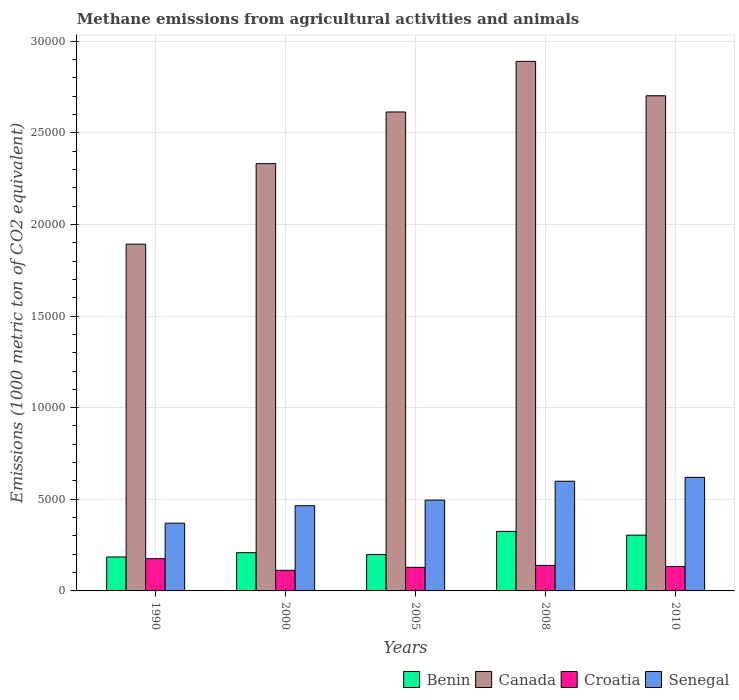How many groups of bars are there?
Make the answer very short. 5. Are the number of bars per tick equal to the number of legend labels?
Provide a short and direct response. Yes. How many bars are there on the 3rd tick from the left?
Provide a succinct answer. 4. How many bars are there on the 4th tick from the right?
Provide a succinct answer. 4. In how many cases, is the number of bars for a given year not equal to the number of legend labels?
Your response must be concise. 0. What is the amount of methane emitted in Canada in 2008?
Your response must be concise. 2.89e+04. Across all years, what is the maximum amount of methane emitted in Canada?
Your response must be concise. 2.89e+04. Across all years, what is the minimum amount of methane emitted in Benin?
Give a very brief answer. 1853. What is the total amount of methane emitted in Canada in the graph?
Make the answer very short. 1.24e+05. What is the difference between the amount of methane emitted in Croatia in 2000 and that in 2005?
Offer a very short reply. -160.7. What is the difference between the amount of methane emitted in Senegal in 2010 and the amount of methane emitted in Benin in 1990?
Give a very brief answer. 4346.1. What is the average amount of methane emitted in Benin per year?
Provide a short and direct response. 2444.08. In the year 2010, what is the difference between the amount of methane emitted in Canada and amount of methane emitted in Benin?
Offer a terse response. 2.40e+04. In how many years, is the amount of methane emitted in Croatia greater than 14000 1000 metric ton?
Your answer should be very brief. 0. What is the ratio of the amount of methane emitted in Croatia in 2005 to that in 2008?
Give a very brief answer. 0.92. What is the difference between the highest and the second highest amount of methane emitted in Croatia?
Offer a terse response. 366.3. What is the difference between the highest and the lowest amount of methane emitted in Canada?
Offer a very short reply. 9973.1. Is the sum of the amount of methane emitted in Benin in 1990 and 2010 greater than the maximum amount of methane emitted in Canada across all years?
Your answer should be very brief. No. Is it the case that in every year, the sum of the amount of methane emitted in Senegal and amount of methane emitted in Benin is greater than the sum of amount of methane emitted in Croatia and amount of methane emitted in Canada?
Your answer should be very brief. No. What does the 3rd bar from the left in 2000 represents?
Provide a short and direct response. Croatia. What does the 2nd bar from the right in 1990 represents?
Make the answer very short. Croatia. Is it the case that in every year, the sum of the amount of methane emitted in Canada and amount of methane emitted in Benin is greater than the amount of methane emitted in Croatia?
Offer a very short reply. Yes. Are all the bars in the graph horizontal?
Offer a very short reply. No. What is the difference between two consecutive major ticks on the Y-axis?
Make the answer very short. 5000. Does the graph contain any zero values?
Provide a succinct answer. No. Does the graph contain grids?
Offer a very short reply. Yes. How many legend labels are there?
Ensure brevity in your answer.  4. What is the title of the graph?
Offer a very short reply. Methane emissions from agricultural activities and animals. Does "Myanmar" appear as one of the legend labels in the graph?
Give a very brief answer. No. What is the label or title of the X-axis?
Provide a succinct answer. Years. What is the label or title of the Y-axis?
Your answer should be compact. Emissions (1000 metric ton of CO2 equivalent). What is the Emissions (1000 metric ton of CO2 equivalent) of Benin in 1990?
Give a very brief answer. 1853. What is the Emissions (1000 metric ton of CO2 equivalent) in Canada in 1990?
Your answer should be compact. 1.89e+04. What is the Emissions (1000 metric ton of CO2 equivalent) in Croatia in 1990?
Provide a short and direct response. 1759.1. What is the Emissions (1000 metric ton of CO2 equivalent) in Senegal in 1990?
Your answer should be compact. 3695.6. What is the Emissions (1000 metric ton of CO2 equivalent) of Benin in 2000?
Offer a very short reply. 2086.3. What is the Emissions (1000 metric ton of CO2 equivalent) in Canada in 2000?
Your answer should be compact. 2.33e+04. What is the Emissions (1000 metric ton of CO2 equivalent) of Croatia in 2000?
Offer a terse response. 1124.5. What is the Emissions (1000 metric ton of CO2 equivalent) in Senegal in 2000?
Ensure brevity in your answer.  4650.7. What is the Emissions (1000 metric ton of CO2 equivalent) in Benin in 2005?
Your answer should be compact. 1989.2. What is the Emissions (1000 metric ton of CO2 equivalent) of Canada in 2005?
Offer a very short reply. 2.61e+04. What is the Emissions (1000 metric ton of CO2 equivalent) of Croatia in 2005?
Your answer should be compact. 1285.2. What is the Emissions (1000 metric ton of CO2 equivalent) of Senegal in 2005?
Provide a succinct answer. 4955.1. What is the Emissions (1000 metric ton of CO2 equivalent) in Benin in 2008?
Provide a succinct answer. 3247.6. What is the Emissions (1000 metric ton of CO2 equivalent) of Canada in 2008?
Your answer should be compact. 2.89e+04. What is the Emissions (1000 metric ton of CO2 equivalent) of Croatia in 2008?
Offer a terse response. 1392.8. What is the Emissions (1000 metric ton of CO2 equivalent) of Senegal in 2008?
Keep it short and to the point. 5984.9. What is the Emissions (1000 metric ton of CO2 equivalent) of Benin in 2010?
Offer a terse response. 3044.3. What is the Emissions (1000 metric ton of CO2 equivalent) of Canada in 2010?
Give a very brief answer. 2.70e+04. What is the Emissions (1000 metric ton of CO2 equivalent) of Croatia in 2010?
Provide a short and direct response. 1331.3. What is the Emissions (1000 metric ton of CO2 equivalent) in Senegal in 2010?
Provide a succinct answer. 6199.1. Across all years, what is the maximum Emissions (1000 metric ton of CO2 equivalent) in Benin?
Offer a very short reply. 3247.6. Across all years, what is the maximum Emissions (1000 metric ton of CO2 equivalent) of Canada?
Your answer should be very brief. 2.89e+04. Across all years, what is the maximum Emissions (1000 metric ton of CO2 equivalent) of Croatia?
Your answer should be compact. 1759.1. Across all years, what is the maximum Emissions (1000 metric ton of CO2 equivalent) of Senegal?
Ensure brevity in your answer.  6199.1. Across all years, what is the minimum Emissions (1000 metric ton of CO2 equivalent) of Benin?
Give a very brief answer. 1853. Across all years, what is the minimum Emissions (1000 metric ton of CO2 equivalent) in Canada?
Offer a very short reply. 1.89e+04. Across all years, what is the minimum Emissions (1000 metric ton of CO2 equivalent) in Croatia?
Keep it short and to the point. 1124.5. Across all years, what is the minimum Emissions (1000 metric ton of CO2 equivalent) of Senegal?
Keep it short and to the point. 3695.6. What is the total Emissions (1000 metric ton of CO2 equivalent) of Benin in the graph?
Provide a succinct answer. 1.22e+04. What is the total Emissions (1000 metric ton of CO2 equivalent) of Canada in the graph?
Provide a short and direct response. 1.24e+05. What is the total Emissions (1000 metric ton of CO2 equivalent) of Croatia in the graph?
Offer a terse response. 6892.9. What is the total Emissions (1000 metric ton of CO2 equivalent) of Senegal in the graph?
Offer a terse response. 2.55e+04. What is the difference between the Emissions (1000 metric ton of CO2 equivalent) in Benin in 1990 and that in 2000?
Keep it short and to the point. -233.3. What is the difference between the Emissions (1000 metric ton of CO2 equivalent) in Canada in 1990 and that in 2000?
Your answer should be compact. -4391.7. What is the difference between the Emissions (1000 metric ton of CO2 equivalent) in Croatia in 1990 and that in 2000?
Provide a succinct answer. 634.6. What is the difference between the Emissions (1000 metric ton of CO2 equivalent) in Senegal in 1990 and that in 2000?
Make the answer very short. -955.1. What is the difference between the Emissions (1000 metric ton of CO2 equivalent) in Benin in 1990 and that in 2005?
Your answer should be compact. -136.2. What is the difference between the Emissions (1000 metric ton of CO2 equivalent) of Canada in 1990 and that in 2005?
Your answer should be compact. -7210.8. What is the difference between the Emissions (1000 metric ton of CO2 equivalent) of Croatia in 1990 and that in 2005?
Your answer should be very brief. 473.9. What is the difference between the Emissions (1000 metric ton of CO2 equivalent) in Senegal in 1990 and that in 2005?
Your response must be concise. -1259.5. What is the difference between the Emissions (1000 metric ton of CO2 equivalent) of Benin in 1990 and that in 2008?
Your response must be concise. -1394.6. What is the difference between the Emissions (1000 metric ton of CO2 equivalent) of Canada in 1990 and that in 2008?
Keep it short and to the point. -9973.1. What is the difference between the Emissions (1000 metric ton of CO2 equivalent) in Croatia in 1990 and that in 2008?
Provide a short and direct response. 366.3. What is the difference between the Emissions (1000 metric ton of CO2 equivalent) in Senegal in 1990 and that in 2008?
Provide a succinct answer. -2289.3. What is the difference between the Emissions (1000 metric ton of CO2 equivalent) of Benin in 1990 and that in 2010?
Your answer should be compact. -1191.3. What is the difference between the Emissions (1000 metric ton of CO2 equivalent) of Canada in 1990 and that in 2010?
Offer a very short reply. -8095.8. What is the difference between the Emissions (1000 metric ton of CO2 equivalent) in Croatia in 1990 and that in 2010?
Your answer should be very brief. 427.8. What is the difference between the Emissions (1000 metric ton of CO2 equivalent) of Senegal in 1990 and that in 2010?
Your response must be concise. -2503.5. What is the difference between the Emissions (1000 metric ton of CO2 equivalent) of Benin in 2000 and that in 2005?
Your answer should be very brief. 97.1. What is the difference between the Emissions (1000 metric ton of CO2 equivalent) of Canada in 2000 and that in 2005?
Your response must be concise. -2819.1. What is the difference between the Emissions (1000 metric ton of CO2 equivalent) of Croatia in 2000 and that in 2005?
Make the answer very short. -160.7. What is the difference between the Emissions (1000 metric ton of CO2 equivalent) in Senegal in 2000 and that in 2005?
Your answer should be very brief. -304.4. What is the difference between the Emissions (1000 metric ton of CO2 equivalent) in Benin in 2000 and that in 2008?
Provide a succinct answer. -1161.3. What is the difference between the Emissions (1000 metric ton of CO2 equivalent) of Canada in 2000 and that in 2008?
Ensure brevity in your answer.  -5581.4. What is the difference between the Emissions (1000 metric ton of CO2 equivalent) of Croatia in 2000 and that in 2008?
Your answer should be compact. -268.3. What is the difference between the Emissions (1000 metric ton of CO2 equivalent) of Senegal in 2000 and that in 2008?
Make the answer very short. -1334.2. What is the difference between the Emissions (1000 metric ton of CO2 equivalent) of Benin in 2000 and that in 2010?
Make the answer very short. -958. What is the difference between the Emissions (1000 metric ton of CO2 equivalent) in Canada in 2000 and that in 2010?
Keep it short and to the point. -3704.1. What is the difference between the Emissions (1000 metric ton of CO2 equivalent) in Croatia in 2000 and that in 2010?
Provide a short and direct response. -206.8. What is the difference between the Emissions (1000 metric ton of CO2 equivalent) of Senegal in 2000 and that in 2010?
Make the answer very short. -1548.4. What is the difference between the Emissions (1000 metric ton of CO2 equivalent) of Benin in 2005 and that in 2008?
Ensure brevity in your answer.  -1258.4. What is the difference between the Emissions (1000 metric ton of CO2 equivalent) in Canada in 2005 and that in 2008?
Offer a terse response. -2762.3. What is the difference between the Emissions (1000 metric ton of CO2 equivalent) of Croatia in 2005 and that in 2008?
Ensure brevity in your answer.  -107.6. What is the difference between the Emissions (1000 metric ton of CO2 equivalent) of Senegal in 2005 and that in 2008?
Make the answer very short. -1029.8. What is the difference between the Emissions (1000 metric ton of CO2 equivalent) of Benin in 2005 and that in 2010?
Keep it short and to the point. -1055.1. What is the difference between the Emissions (1000 metric ton of CO2 equivalent) of Canada in 2005 and that in 2010?
Your response must be concise. -885. What is the difference between the Emissions (1000 metric ton of CO2 equivalent) in Croatia in 2005 and that in 2010?
Your answer should be compact. -46.1. What is the difference between the Emissions (1000 metric ton of CO2 equivalent) in Senegal in 2005 and that in 2010?
Your response must be concise. -1244. What is the difference between the Emissions (1000 metric ton of CO2 equivalent) of Benin in 2008 and that in 2010?
Provide a short and direct response. 203.3. What is the difference between the Emissions (1000 metric ton of CO2 equivalent) of Canada in 2008 and that in 2010?
Your response must be concise. 1877.3. What is the difference between the Emissions (1000 metric ton of CO2 equivalent) of Croatia in 2008 and that in 2010?
Provide a succinct answer. 61.5. What is the difference between the Emissions (1000 metric ton of CO2 equivalent) in Senegal in 2008 and that in 2010?
Your answer should be compact. -214.2. What is the difference between the Emissions (1000 metric ton of CO2 equivalent) in Benin in 1990 and the Emissions (1000 metric ton of CO2 equivalent) in Canada in 2000?
Provide a short and direct response. -2.15e+04. What is the difference between the Emissions (1000 metric ton of CO2 equivalent) in Benin in 1990 and the Emissions (1000 metric ton of CO2 equivalent) in Croatia in 2000?
Your response must be concise. 728.5. What is the difference between the Emissions (1000 metric ton of CO2 equivalent) in Benin in 1990 and the Emissions (1000 metric ton of CO2 equivalent) in Senegal in 2000?
Your answer should be very brief. -2797.7. What is the difference between the Emissions (1000 metric ton of CO2 equivalent) of Canada in 1990 and the Emissions (1000 metric ton of CO2 equivalent) of Croatia in 2000?
Make the answer very short. 1.78e+04. What is the difference between the Emissions (1000 metric ton of CO2 equivalent) of Canada in 1990 and the Emissions (1000 metric ton of CO2 equivalent) of Senegal in 2000?
Make the answer very short. 1.43e+04. What is the difference between the Emissions (1000 metric ton of CO2 equivalent) of Croatia in 1990 and the Emissions (1000 metric ton of CO2 equivalent) of Senegal in 2000?
Make the answer very short. -2891.6. What is the difference between the Emissions (1000 metric ton of CO2 equivalent) of Benin in 1990 and the Emissions (1000 metric ton of CO2 equivalent) of Canada in 2005?
Give a very brief answer. -2.43e+04. What is the difference between the Emissions (1000 metric ton of CO2 equivalent) in Benin in 1990 and the Emissions (1000 metric ton of CO2 equivalent) in Croatia in 2005?
Make the answer very short. 567.8. What is the difference between the Emissions (1000 metric ton of CO2 equivalent) of Benin in 1990 and the Emissions (1000 metric ton of CO2 equivalent) of Senegal in 2005?
Your answer should be compact. -3102.1. What is the difference between the Emissions (1000 metric ton of CO2 equivalent) of Canada in 1990 and the Emissions (1000 metric ton of CO2 equivalent) of Croatia in 2005?
Ensure brevity in your answer.  1.76e+04. What is the difference between the Emissions (1000 metric ton of CO2 equivalent) of Canada in 1990 and the Emissions (1000 metric ton of CO2 equivalent) of Senegal in 2005?
Make the answer very short. 1.40e+04. What is the difference between the Emissions (1000 metric ton of CO2 equivalent) of Croatia in 1990 and the Emissions (1000 metric ton of CO2 equivalent) of Senegal in 2005?
Your answer should be very brief. -3196. What is the difference between the Emissions (1000 metric ton of CO2 equivalent) in Benin in 1990 and the Emissions (1000 metric ton of CO2 equivalent) in Canada in 2008?
Keep it short and to the point. -2.70e+04. What is the difference between the Emissions (1000 metric ton of CO2 equivalent) of Benin in 1990 and the Emissions (1000 metric ton of CO2 equivalent) of Croatia in 2008?
Ensure brevity in your answer.  460.2. What is the difference between the Emissions (1000 metric ton of CO2 equivalent) in Benin in 1990 and the Emissions (1000 metric ton of CO2 equivalent) in Senegal in 2008?
Offer a very short reply. -4131.9. What is the difference between the Emissions (1000 metric ton of CO2 equivalent) of Canada in 1990 and the Emissions (1000 metric ton of CO2 equivalent) of Croatia in 2008?
Provide a succinct answer. 1.75e+04. What is the difference between the Emissions (1000 metric ton of CO2 equivalent) of Canada in 1990 and the Emissions (1000 metric ton of CO2 equivalent) of Senegal in 2008?
Your response must be concise. 1.29e+04. What is the difference between the Emissions (1000 metric ton of CO2 equivalent) of Croatia in 1990 and the Emissions (1000 metric ton of CO2 equivalent) of Senegal in 2008?
Your answer should be very brief. -4225.8. What is the difference between the Emissions (1000 metric ton of CO2 equivalent) of Benin in 1990 and the Emissions (1000 metric ton of CO2 equivalent) of Canada in 2010?
Your answer should be compact. -2.52e+04. What is the difference between the Emissions (1000 metric ton of CO2 equivalent) of Benin in 1990 and the Emissions (1000 metric ton of CO2 equivalent) of Croatia in 2010?
Offer a terse response. 521.7. What is the difference between the Emissions (1000 metric ton of CO2 equivalent) of Benin in 1990 and the Emissions (1000 metric ton of CO2 equivalent) of Senegal in 2010?
Keep it short and to the point. -4346.1. What is the difference between the Emissions (1000 metric ton of CO2 equivalent) of Canada in 1990 and the Emissions (1000 metric ton of CO2 equivalent) of Croatia in 2010?
Offer a terse response. 1.76e+04. What is the difference between the Emissions (1000 metric ton of CO2 equivalent) of Canada in 1990 and the Emissions (1000 metric ton of CO2 equivalent) of Senegal in 2010?
Give a very brief answer. 1.27e+04. What is the difference between the Emissions (1000 metric ton of CO2 equivalent) in Croatia in 1990 and the Emissions (1000 metric ton of CO2 equivalent) in Senegal in 2010?
Give a very brief answer. -4440. What is the difference between the Emissions (1000 metric ton of CO2 equivalent) in Benin in 2000 and the Emissions (1000 metric ton of CO2 equivalent) in Canada in 2005?
Provide a short and direct response. -2.40e+04. What is the difference between the Emissions (1000 metric ton of CO2 equivalent) in Benin in 2000 and the Emissions (1000 metric ton of CO2 equivalent) in Croatia in 2005?
Provide a succinct answer. 801.1. What is the difference between the Emissions (1000 metric ton of CO2 equivalent) of Benin in 2000 and the Emissions (1000 metric ton of CO2 equivalent) of Senegal in 2005?
Give a very brief answer. -2868.8. What is the difference between the Emissions (1000 metric ton of CO2 equivalent) in Canada in 2000 and the Emissions (1000 metric ton of CO2 equivalent) in Croatia in 2005?
Offer a very short reply. 2.20e+04. What is the difference between the Emissions (1000 metric ton of CO2 equivalent) in Canada in 2000 and the Emissions (1000 metric ton of CO2 equivalent) in Senegal in 2005?
Ensure brevity in your answer.  1.84e+04. What is the difference between the Emissions (1000 metric ton of CO2 equivalent) in Croatia in 2000 and the Emissions (1000 metric ton of CO2 equivalent) in Senegal in 2005?
Make the answer very short. -3830.6. What is the difference between the Emissions (1000 metric ton of CO2 equivalent) in Benin in 2000 and the Emissions (1000 metric ton of CO2 equivalent) in Canada in 2008?
Provide a short and direct response. -2.68e+04. What is the difference between the Emissions (1000 metric ton of CO2 equivalent) of Benin in 2000 and the Emissions (1000 metric ton of CO2 equivalent) of Croatia in 2008?
Offer a terse response. 693.5. What is the difference between the Emissions (1000 metric ton of CO2 equivalent) of Benin in 2000 and the Emissions (1000 metric ton of CO2 equivalent) of Senegal in 2008?
Your answer should be very brief. -3898.6. What is the difference between the Emissions (1000 metric ton of CO2 equivalent) in Canada in 2000 and the Emissions (1000 metric ton of CO2 equivalent) in Croatia in 2008?
Offer a very short reply. 2.19e+04. What is the difference between the Emissions (1000 metric ton of CO2 equivalent) of Canada in 2000 and the Emissions (1000 metric ton of CO2 equivalent) of Senegal in 2008?
Offer a terse response. 1.73e+04. What is the difference between the Emissions (1000 metric ton of CO2 equivalent) in Croatia in 2000 and the Emissions (1000 metric ton of CO2 equivalent) in Senegal in 2008?
Your answer should be very brief. -4860.4. What is the difference between the Emissions (1000 metric ton of CO2 equivalent) of Benin in 2000 and the Emissions (1000 metric ton of CO2 equivalent) of Canada in 2010?
Your answer should be very brief. -2.49e+04. What is the difference between the Emissions (1000 metric ton of CO2 equivalent) in Benin in 2000 and the Emissions (1000 metric ton of CO2 equivalent) in Croatia in 2010?
Offer a very short reply. 755. What is the difference between the Emissions (1000 metric ton of CO2 equivalent) of Benin in 2000 and the Emissions (1000 metric ton of CO2 equivalent) of Senegal in 2010?
Ensure brevity in your answer.  -4112.8. What is the difference between the Emissions (1000 metric ton of CO2 equivalent) of Canada in 2000 and the Emissions (1000 metric ton of CO2 equivalent) of Croatia in 2010?
Offer a terse response. 2.20e+04. What is the difference between the Emissions (1000 metric ton of CO2 equivalent) in Canada in 2000 and the Emissions (1000 metric ton of CO2 equivalent) in Senegal in 2010?
Give a very brief answer. 1.71e+04. What is the difference between the Emissions (1000 metric ton of CO2 equivalent) of Croatia in 2000 and the Emissions (1000 metric ton of CO2 equivalent) of Senegal in 2010?
Ensure brevity in your answer.  -5074.6. What is the difference between the Emissions (1000 metric ton of CO2 equivalent) in Benin in 2005 and the Emissions (1000 metric ton of CO2 equivalent) in Canada in 2008?
Provide a succinct answer. -2.69e+04. What is the difference between the Emissions (1000 metric ton of CO2 equivalent) in Benin in 2005 and the Emissions (1000 metric ton of CO2 equivalent) in Croatia in 2008?
Offer a very short reply. 596.4. What is the difference between the Emissions (1000 metric ton of CO2 equivalent) in Benin in 2005 and the Emissions (1000 metric ton of CO2 equivalent) in Senegal in 2008?
Give a very brief answer. -3995.7. What is the difference between the Emissions (1000 metric ton of CO2 equivalent) in Canada in 2005 and the Emissions (1000 metric ton of CO2 equivalent) in Croatia in 2008?
Provide a succinct answer. 2.47e+04. What is the difference between the Emissions (1000 metric ton of CO2 equivalent) in Canada in 2005 and the Emissions (1000 metric ton of CO2 equivalent) in Senegal in 2008?
Offer a very short reply. 2.01e+04. What is the difference between the Emissions (1000 metric ton of CO2 equivalent) of Croatia in 2005 and the Emissions (1000 metric ton of CO2 equivalent) of Senegal in 2008?
Make the answer very short. -4699.7. What is the difference between the Emissions (1000 metric ton of CO2 equivalent) in Benin in 2005 and the Emissions (1000 metric ton of CO2 equivalent) in Canada in 2010?
Make the answer very short. -2.50e+04. What is the difference between the Emissions (1000 metric ton of CO2 equivalent) in Benin in 2005 and the Emissions (1000 metric ton of CO2 equivalent) in Croatia in 2010?
Ensure brevity in your answer.  657.9. What is the difference between the Emissions (1000 metric ton of CO2 equivalent) of Benin in 2005 and the Emissions (1000 metric ton of CO2 equivalent) of Senegal in 2010?
Ensure brevity in your answer.  -4209.9. What is the difference between the Emissions (1000 metric ton of CO2 equivalent) in Canada in 2005 and the Emissions (1000 metric ton of CO2 equivalent) in Croatia in 2010?
Offer a terse response. 2.48e+04. What is the difference between the Emissions (1000 metric ton of CO2 equivalent) in Canada in 2005 and the Emissions (1000 metric ton of CO2 equivalent) in Senegal in 2010?
Provide a succinct answer. 1.99e+04. What is the difference between the Emissions (1000 metric ton of CO2 equivalent) in Croatia in 2005 and the Emissions (1000 metric ton of CO2 equivalent) in Senegal in 2010?
Your response must be concise. -4913.9. What is the difference between the Emissions (1000 metric ton of CO2 equivalent) of Benin in 2008 and the Emissions (1000 metric ton of CO2 equivalent) of Canada in 2010?
Give a very brief answer. -2.38e+04. What is the difference between the Emissions (1000 metric ton of CO2 equivalent) in Benin in 2008 and the Emissions (1000 metric ton of CO2 equivalent) in Croatia in 2010?
Your response must be concise. 1916.3. What is the difference between the Emissions (1000 metric ton of CO2 equivalent) of Benin in 2008 and the Emissions (1000 metric ton of CO2 equivalent) of Senegal in 2010?
Offer a terse response. -2951.5. What is the difference between the Emissions (1000 metric ton of CO2 equivalent) of Canada in 2008 and the Emissions (1000 metric ton of CO2 equivalent) of Croatia in 2010?
Ensure brevity in your answer.  2.76e+04. What is the difference between the Emissions (1000 metric ton of CO2 equivalent) of Canada in 2008 and the Emissions (1000 metric ton of CO2 equivalent) of Senegal in 2010?
Your answer should be compact. 2.27e+04. What is the difference between the Emissions (1000 metric ton of CO2 equivalent) in Croatia in 2008 and the Emissions (1000 metric ton of CO2 equivalent) in Senegal in 2010?
Give a very brief answer. -4806.3. What is the average Emissions (1000 metric ton of CO2 equivalent) of Benin per year?
Keep it short and to the point. 2444.08. What is the average Emissions (1000 metric ton of CO2 equivalent) of Canada per year?
Make the answer very short. 2.49e+04. What is the average Emissions (1000 metric ton of CO2 equivalent) in Croatia per year?
Your answer should be very brief. 1378.58. What is the average Emissions (1000 metric ton of CO2 equivalent) in Senegal per year?
Your answer should be compact. 5097.08. In the year 1990, what is the difference between the Emissions (1000 metric ton of CO2 equivalent) of Benin and Emissions (1000 metric ton of CO2 equivalent) of Canada?
Your answer should be very brief. -1.71e+04. In the year 1990, what is the difference between the Emissions (1000 metric ton of CO2 equivalent) of Benin and Emissions (1000 metric ton of CO2 equivalent) of Croatia?
Your response must be concise. 93.9. In the year 1990, what is the difference between the Emissions (1000 metric ton of CO2 equivalent) of Benin and Emissions (1000 metric ton of CO2 equivalent) of Senegal?
Provide a succinct answer. -1842.6. In the year 1990, what is the difference between the Emissions (1000 metric ton of CO2 equivalent) of Canada and Emissions (1000 metric ton of CO2 equivalent) of Croatia?
Your answer should be very brief. 1.72e+04. In the year 1990, what is the difference between the Emissions (1000 metric ton of CO2 equivalent) of Canada and Emissions (1000 metric ton of CO2 equivalent) of Senegal?
Offer a terse response. 1.52e+04. In the year 1990, what is the difference between the Emissions (1000 metric ton of CO2 equivalent) in Croatia and Emissions (1000 metric ton of CO2 equivalent) in Senegal?
Provide a succinct answer. -1936.5. In the year 2000, what is the difference between the Emissions (1000 metric ton of CO2 equivalent) in Benin and Emissions (1000 metric ton of CO2 equivalent) in Canada?
Give a very brief answer. -2.12e+04. In the year 2000, what is the difference between the Emissions (1000 metric ton of CO2 equivalent) in Benin and Emissions (1000 metric ton of CO2 equivalent) in Croatia?
Your answer should be very brief. 961.8. In the year 2000, what is the difference between the Emissions (1000 metric ton of CO2 equivalent) in Benin and Emissions (1000 metric ton of CO2 equivalent) in Senegal?
Offer a terse response. -2564.4. In the year 2000, what is the difference between the Emissions (1000 metric ton of CO2 equivalent) in Canada and Emissions (1000 metric ton of CO2 equivalent) in Croatia?
Your answer should be compact. 2.22e+04. In the year 2000, what is the difference between the Emissions (1000 metric ton of CO2 equivalent) of Canada and Emissions (1000 metric ton of CO2 equivalent) of Senegal?
Provide a succinct answer. 1.87e+04. In the year 2000, what is the difference between the Emissions (1000 metric ton of CO2 equivalent) of Croatia and Emissions (1000 metric ton of CO2 equivalent) of Senegal?
Offer a terse response. -3526.2. In the year 2005, what is the difference between the Emissions (1000 metric ton of CO2 equivalent) of Benin and Emissions (1000 metric ton of CO2 equivalent) of Canada?
Your response must be concise. -2.41e+04. In the year 2005, what is the difference between the Emissions (1000 metric ton of CO2 equivalent) of Benin and Emissions (1000 metric ton of CO2 equivalent) of Croatia?
Ensure brevity in your answer.  704. In the year 2005, what is the difference between the Emissions (1000 metric ton of CO2 equivalent) of Benin and Emissions (1000 metric ton of CO2 equivalent) of Senegal?
Give a very brief answer. -2965.9. In the year 2005, what is the difference between the Emissions (1000 metric ton of CO2 equivalent) in Canada and Emissions (1000 metric ton of CO2 equivalent) in Croatia?
Give a very brief answer. 2.48e+04. In the year 2005, what is the difference between the Emissions (1000 metric ton of CO2 equivalent) of Canada and Emissions (1000 metric ton of CO2 equivalent) of Senegal?
Your answer should be very brief. 2.12e+04. In the year 2005, what is the difference between the Emissions (1000 metric ton of CO2 equivalent) in Croatia and Emissions (1000 metric ton of CO2 equivalent) in Senegal?
Provide a short and direct response. -3669.9. In the year 2008, what is the difference between the Emissions (1000 metric ton of CO2 equivalent) in Benin and Emissions (1000 metric ton of CO2 equivalent) in Canada?
Your answer should be very brief. -2.56e+04. In the year 2008, what is the difference between the Emissions (1000 metric ton of CO2 equivalent) of Benin and Emissions (1000 metric ton of CO2 equivalent) of Croatia?
Your answer should be very brief. 1854.8. In the year 2008, what is the difference between the Emissions (1000 metric ton of CO2 equivalent) in Benin and Emissions (1000 metric ton of CO2 equivalent) in Senegal?
Your answer should be compact. -2737.3. In the year 2008, what is the difference between the Emissions (1000 metric ton of CO2 equivalent) in Canada and Emissions (1000 metric ton of CO2 equivalent) in Croatia?
Your response must be concise. 2.75e+04. In the year 2008, what is the difference between the Emissions (1000 metric ton of CO2 equivalent) in Canada and Emissions (1000 metric ton of CO2 equivalent) in Senegal?
Your answer should be very brief. 2.29e+04. In the year 2008, what is the difference between the Emissions (1000 metric ton of CO2 equivalent) of Croatia and Emissions (1000 metric ton of CO2 equivalent) of Senegal?
Make the answer very short. -4592.1. In the year 2010, what is the difference between the Emissions (1000 metric ton of CO2 equivalent) in Benin and Emissions (1000 metric ton of CO2 equivalent) in Canada?
Make the answer very short. -2.40e+04. In the year 2010, what is the difference between the Emissions (1000 metric ton of CO2 equivalent) of Benin and Emissions (1000 metric ton of CO2 equivalent) of Croatia?
Your answer should be compact. 1713. In the year 2010, what is the difference between the Emissions (1000 metric ton of CO2 equivalent) of Benin and Emissions (1000 metric ton of CO2 equivalent) of Senegal?
Make the answer very short. -3154.8. In the year 2010, what is the difference between the Emissions (1000 metric ton of CO2 equivalent) of Canada and Emissions (1000 metric ton of CO2 equivalent) of Croatia?
Your response must be concise. 2.57e+04. In the year 2010, what is the difference between the Emissions (1000 metric ton of CO2 equivalent) of Canada and Emissions (1000 metric ton of CO2 equivalent) of Senegal?
Provide a short and direct response. 2.08e+04. In the year 2010, what is the difference between the Emissions (1000 metric ton of CO2 equivalent) of Croatia and Emissions (1000 metric ton of CO2 equivalent) of Senegal?
Give a very brief answer. -4867.8. What is the ratio of the Emissions (1000 metric ton of CO2 equivalent) of Benin in 1990 to that in 2000?
Ensure brevity in your answer.  0.89. What is the ratio of the Emissions (1000 metric ton of CO2 equivalent) in Canada in 1990 to that in 2000?
Provide a short and direct response. 0.81. What is the ratio of the Emissions (1000 metric ton of CO2 equivalent) in Croatia in 1990 to that in 2000?
Your answer should be very brief. 1.56. What is the ratio of the Emissions (1000 metric ton of CO2 equivalent) of Senegal in 1990 to that in 2000?
Your answer should be compact. 0.79. What is the ratio of the Emissions (1000 metric ton of CO2 equivalent) of Benin in 1990 to that in 2005?
Offer a very short reply. 0.93. What is the ratio of the Emissions (1000 metric ton of CO2 equivalent) of Canada in 1990 to that in 2005?
Provide a short and direct response. 0.72. What is the ratio of the Emissions (1000 metric ton of CO2 equivalent) of Croatia in 1990 to that in 2005?
Offer a terse response. 1.37. What is the ratio of the Emissions (1000 metric ton of CO2 equivalent) in Senegal in 1990 to that in 2005?
Your response must be concise. 0.75. What is the ratio of the Emissions (1000 metric ton of CO2 equivalent) of Benin in 1990 to that in 2008?
Provide a short and direct response. 0.57. What is the ratio of the Emissions (1000 metric ton of CO2 equivalent) of Canada in 1990 to that in 2008?
Make the answer very short. 0.65. What is the ratio of the Emissions (1000 metric ton of CO2 equivalent) in Croatia in 1990 to that in 2008?
Your response must be concise. 1.26. What is the ratio of the Emissions (1000 metric ton of CO2 equivalent) of Senegal in 1990 to that in 2008?
Keep it short and to the point. 0.62. What is the ratio of the Emissions (1000 metric ton of CO2 equivalent) of Benin in 1990 to that in 2010?
Your answer should be very brief. 0.61. What is the ratio of the Emissions (1000 metric ton of CO2 equivalent) in Canada in 1990 to that in 2010?
Your answer should be very brief. 0.7. What is the ratio of the Emissions (1000 metric ton of CO2 equivalent) in Croatia in 1990 to that in 2010?
Your answer should be compact. 1.32. What is the ratio of the Emissions (1000 metric ton of CO2 equivalent) of Senegal in 1990 to that in 2010?
Your response must be concise. 0.6. What is the ratio of the Emissions (1000 metric ton of CO2 equivalent) of Benin in 2000 to that in 2005?
Ensure brevity in your answer.  1.05. What is the ratio of the Emissions (1000 metric ton of CO2 equivalent) of Canada in 2000 to that in 2005?
Your response must be concise. 0.89. What is the ratio of the Emissions (1000 metric ton of CO2 equivalent) of Croatia in 2000 to that in 2005?
Your answer should be compact. 0.88. What is the ratio of the Emissions (1000 metric ton of CO2 equivalent) of Senegal in 2000 to that in 2005?
Give a very brief answer. 0.94. What is the ratio of the Emissions (1000 metric ton of CO2 equivalent) in Benin in 2000 to that in 2008?
Keep it short and to the point. 0.64. What is the ratio of the Emissions (1000 metric ton of CO2 equivalent) of Canada in 2000 to that in 2008?
Your response must be concise. 0.81. What is the ratio of the Emissions (1000 metric ton of CO2 equivalent) in Croatia in 2000 to that in 2008?
Keep it short and to the point. 0.81. What is the ratio of the Emissions (1000 metric ton of CO2 equivalent) in Senegal in 2000 to that in 2008?
Keep it short and to the point. 0.78. What is the ratio of the Emissions (1000 metric ton of CO2 equivalent) of Benin in 2000 to that in 2010?
Your answer should be very brief. 0.69. What is the ratio of the Emissions (1000 metric ton of CO2 equivalent) in Canada in 2000 to that in 2010?
Your response must be concise. 0.86. What is the ratio of the Emissions (1000 metric ton of CO2 equivalent) in Croatia in 2000 to that in 2010?
Make the answer very short. 0.84. What is the ratio of the Emissions (1000 metric ton of CO2 equivalent) in Senegal in 2000 to that in 2010?
Provide a succinct answer. 0.75. What is the ratio of the Emissions (1000 metric ton of CO2 equivalent) of Benin in 2005 to that in 2008?
Offer a very short reply. 0.61. What is the ratio of the Emissions (1000 metric ton of CO2 equivalent) of Canada in 2005 to that in 2008?
Make the answer very short. 0.9. What is the ratio of the Emissions (1000 metric ton of CO2 equivalent) of Croatia in 2005 to that in 2008?
Offer a terse response. 0.92. What is the ratio of the Emissions (1000 metric ton of CO2 equivalent) in Senegal in 2005 to that in 2008?
Offer a terse response. 0.83. What is the ratio of the Emissions (1000 metric ton of CO2 equivalent) in Benin in 2005 to that in 2010?
Offer a very short reply. 0.65. What is the ratio of the Emissions (1000 metric ton of CO2 equivalent) in Canada in 2005 to that in 2010?
Your answer should be very brief. 0.97. What is the ratio of the Emissions (1000 metric ton of CO2 equivalent) in Croatia in 2005 to that in 2010?
Provide a short and direct response. 0.97. What is the ratio of the Emissions (1000 metric ton of CO2 equivalent) in Senegal in 2005 to that in 2010?
Make the answer very short. 0.8. What is the ratio of the Emissions (1000 metric ton of CO2 equivalent) of Benin in 2008 to that in 2010?
Keep it short and to the point. 1.07. What is the ratio of the Emissions (1000 metric ton of CO2 equivalent) in Canada in 2008 to that in 2010?
Your response must be concise. 1.07. What is the ratio of the Emissions (1000 metric ton of CO2 equivalent) in Croatia in 2008 to that in 2010?
Your response must be concise. 1.05. What is the ratio of the Emissions (1000 metric ton of CO2 equivalent) of Senegal in 2008 to that in 2010?
Provide a short and direct response. 0.97. What is the difference between the highest and the second highest Emissions (1000 metric ton of CO2 equivalent) in Benin?
Make the answer very short. 203.3. What is the difference between the highest and the second highest Emissions (1000 metric ton of CO2 equivalent) in Canada?
Offer a very short reply. 1877.3. What is the difference between the highest and the second highest Emissions (1000 metric ton of CO2 equivalent) in Croatia?
Keep it short and to the point. 366.3. What is the difference between the highest and the second highest Emissions (1000 metric ton of CO2 equivalent) of Senegal?
Your answer should be compact. 214.2. What is the difference between the highest and the lowest Emissions (1000 metric ton of CO2 equivalent) of Benin?
Your answer should be compact. 1394.6. What is the difference between the highest and the lowest Emissions (1000 metric ton of CO2 equivalent) in Canada?
Your answer should be very brief. 9973.1. What is the difference between the highest and the lowest Emissions (1000 metric ton of CO2 equivalent) of Croatia?
Give a very brief answer. 634.6. What is the difference between the highest and the lowest Emissions (1000 metric ton of CO2 equivalent) of Senegal?
Provide a short and direct response. 2503.5. 